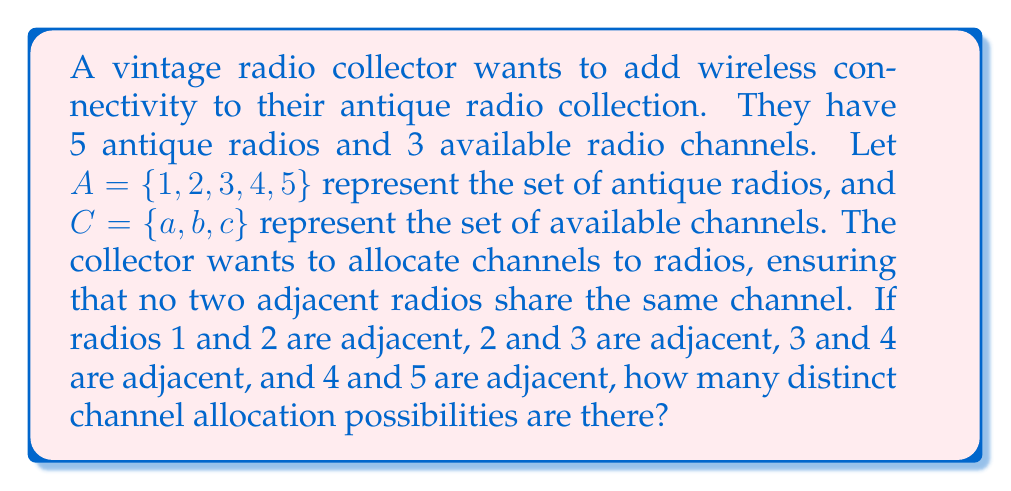Provide a solution to this math problem. Let's approach this step-by-step:

1) First, we need to understand that this problem is essentially about creating a function from set $A$ to set $C$ with certain constraints.

2) We can start allocating channels from radio 1 and move sequentially:

   For radio 1: We have 3 choices (a, b, or c)

3) For radio 2: We can't use the same channel as radio 1, so we have 2 choices

4) For radio 3: We can't use the same channel as radio 2, but we could use the same as radio 1. So we again have 2 choices

5) For radio 4: We can't use the same as radio 3, so 2 choices

6) For radio 5: We can't use the same as radio 4, so 2 choices

7) This scenario follows the multiplication principle. The total number of possibilities is:

   $$ 3 \times 2 \times 2 \times 2 \times 2 = 3 \times 2^4 = 3 \times 16 = 48 $$

Therefore, there are 48 distinct channel allocation possibilities.
Answer: 48 distinct channel allocation possibilities 